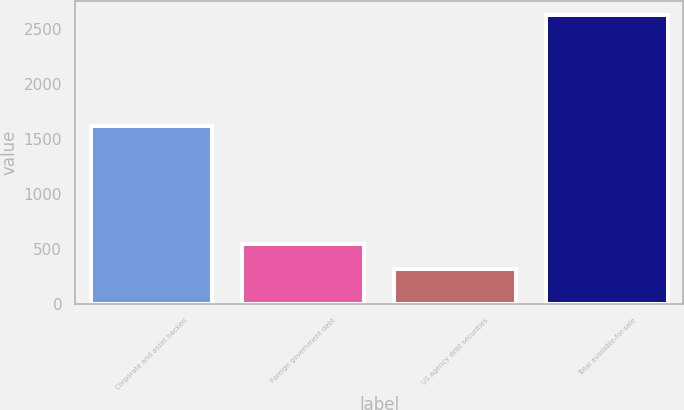Convert chart to OTSL. <chart><loc_0><loc_0><loc_500><loc_500><bar_chart><fcel>Corporate and asset backed<fcel>Foreign government debt<fcel>US agency debt securities<fcel>Total available-for-sale<nl><fcel>1618.4<fcel>544.87<fcel>314.2<fcel>2620.9<nl></chart> 